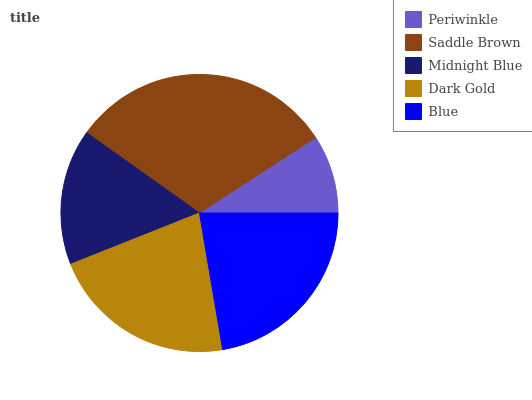Is Periwinkle the minimum?
Answer yes or no. Yes. Is Saddle Brown the maximum?
Answer yes or no. Yes. Is Midnight Blue the minimum?
Answer yes or no. No. Is Midnight Blue the maximum?
Answer yes or no. No. Is Saddle Brown greater than Midnight Blue?
Answer yes or no. Yes. Is Midnight Blue less than Saddle Brown?
Answer yes or no. Yes. Is Midnight Blue greater than Saddle Brown?
Answer yes or no. No. Is Saddle Brown less than Midnight Blue?
Answer yes or no. No. Is Dark Gold the high median?
Answer yes or no. Yes. Is Dark Gold the low median?
Answer yes or no. Yes. Is Saddle Brown the high median?
Answer yes or no. No. Is Midnight Blue the low median?
Answer yes or no. No. 